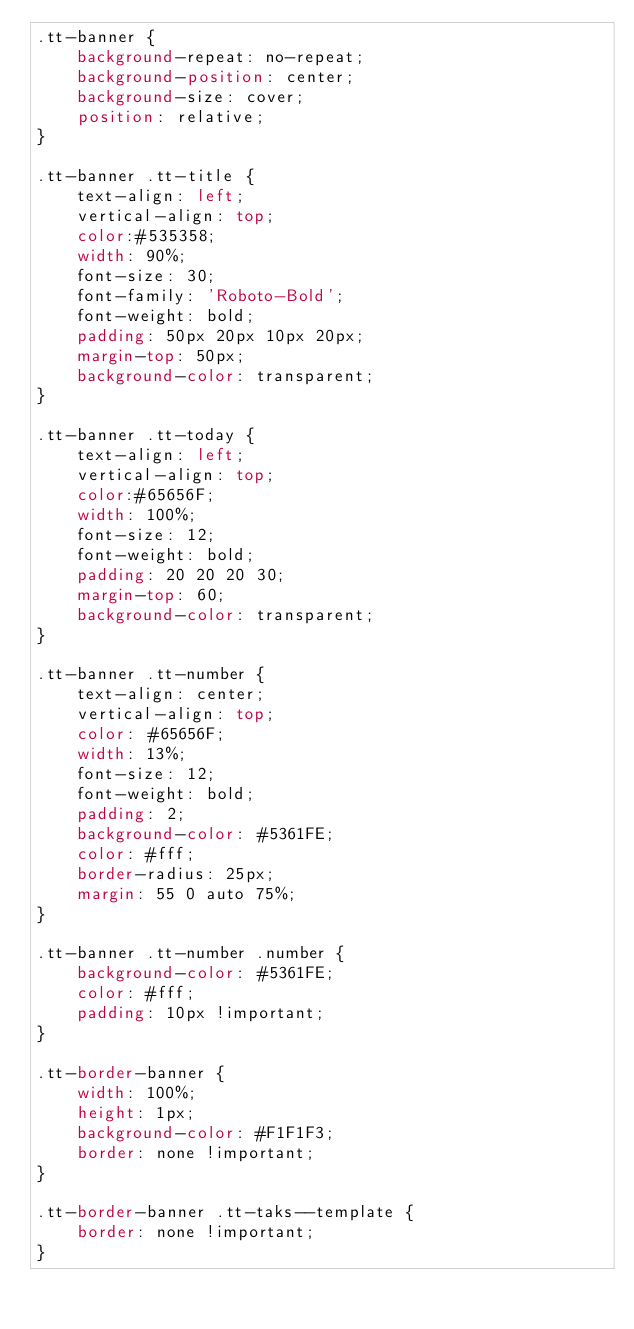Convert code to text. <code><loc_0><loc_0><loc_500><loc_500><_CSS_>.tt-banner {
    background-repeat: no-repeat;
    background-position: center;
    background-size: cover;
    position: relative;
}

.tt-banner .tt-title {
    text-align: left;
    vertical-align: top;
    color:#535358;
    width: 90%;
    font-size: 30;
    font-family: 'Roboto-Bold';
    font-weight: bold;
    padding: 50px 20px 10px 20px;
    margin-top: 50px;
    background-color: transparent;
}

.tt-banner .tt-today {
    text-align: left;
    vertical-align: top;
    color:#65656F;
    width: 100%;
    font-size: 12;
    font-weight: bold;
    padding: 20 20 20 30;
    margin-top: 60;
    background-color: transparent;
}

.tt-banner .tt-number {
    text-align: center;
    vertical-align: top;
    color: #65656F;
    width: 13%;
    font-size: 12;
    font-weight: bold;
    padding: 2;
    background-color: #5361FE;
    color: #fff;
    border-radius: 25px;
    margin: 55 0 auto 75%;
}

.tt-banner .tt-number .number {
    background-color: #5361FE;
    color: #fff;
    padding: 10px !important;
}

.tt-border-banner {
    width: 100%;
    height: 1px;
    background-color: #F1F1F3;
    border: none !important;
}

.tt-border-banner .tt-taks--template {
    border: none !important;
}</code> 